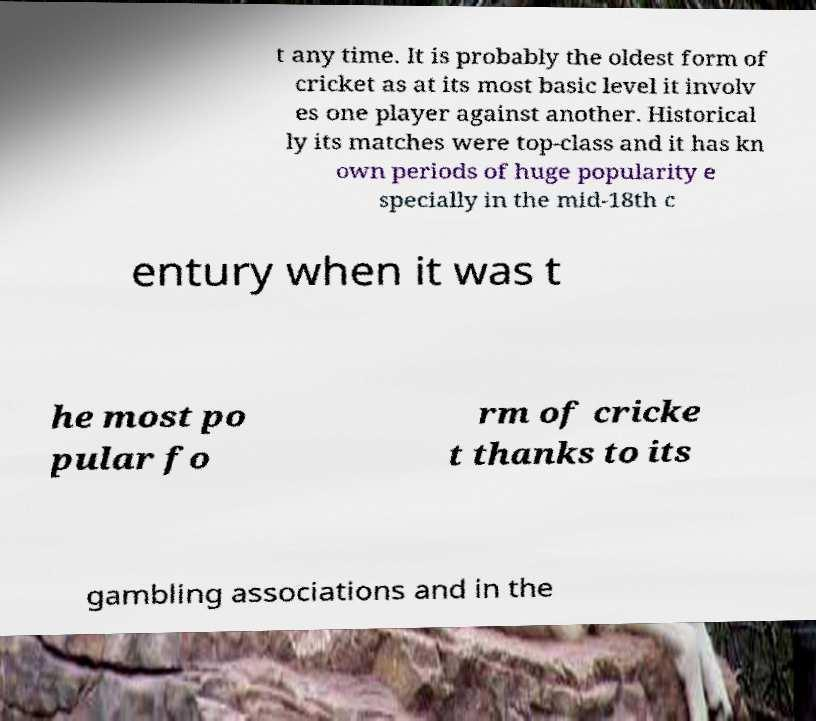Please identify and transcribe the text found in this image. t any time. It is probably the oldest form of cricket as at its most basic level it involv es one player against another. Historical ly its matches were top-class and it has kn own periods of huge popularity e specially in the mid-18th c entury when it was t he most po pular fo rm of cricke t thanks to its gambling associations and in the 